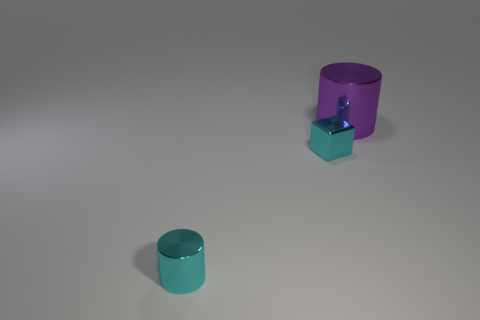What number of big cylinders are behind the small cyan thing that is on the left side of the metal cube?
Keep it short and to the point. 1. There is a small thing that is made of the same material as the cyan cylinder; what shape is it?
Keep it short and to the point. Cube. What number of cyan things are small objects or tiny cylinders?
Ensure brevity in your answer.  2. There is a tiny cyan thing to the left of the small cyan object that is behind the tiny metal cylinder; is there a small metallic thing that is right of it?
Give a very brief answer. Yes. Is the number of tiny things less than the number of tiny metal cylinders?
Keep it short and to the point. No. Do the small metallic thing on the left side of the shiny cube and the large metal thing have the same shape?
Offer a terse response. Yes. Are any big yellow metal things visible?
Give a very brief answer. No. The cylinder that is in front of the big purple shiny cylinder that is to the right of the cylinder that is in front of the big metal cylinder is what color?
Provide a succinct answer. Cyan. Are there an equal number of cyan metallic blocks on the left side of the small cube and big things that are right of the big purple shiny cylinder?
Your answer should be compact. Yes. What shape is the object that is the same size as the metal cube?
Your response must be concise. Cylinder. 